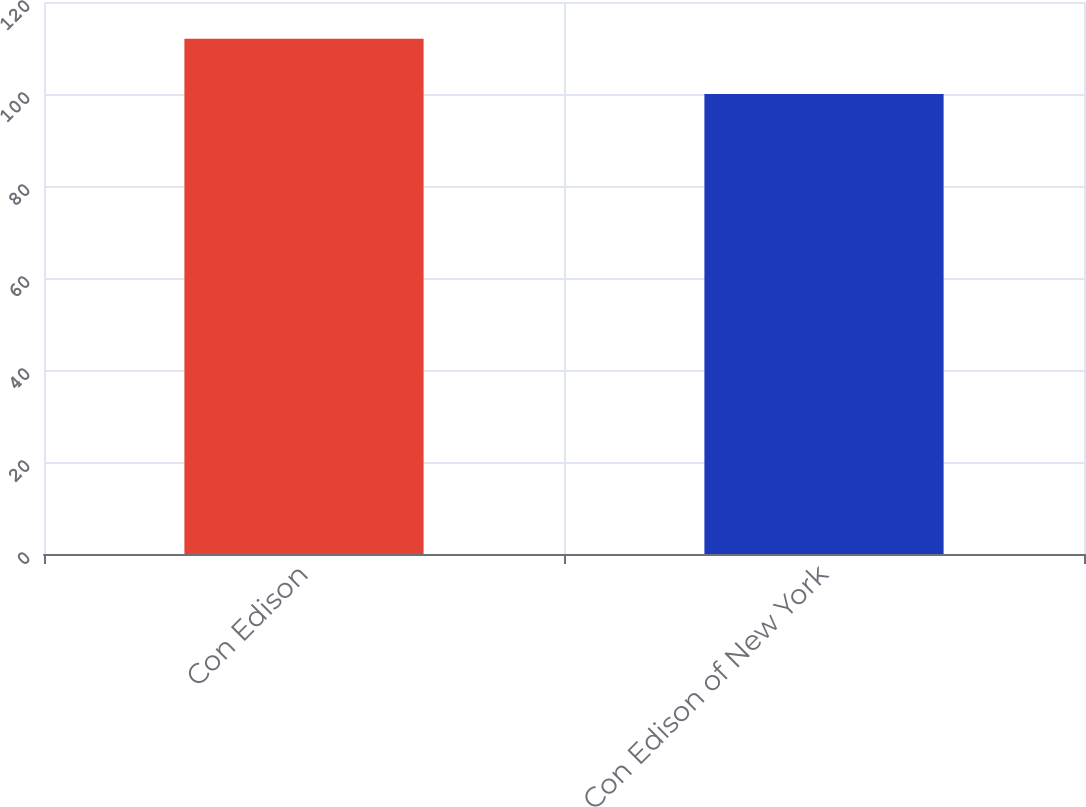Convert chart. <chart><loc_0><loc_0><loc_500><loc_500><bar_chart><fcel>Con Edison<fcel>Con Edison of New York<nl><fcel>112<fcel>100<nl></chart> 